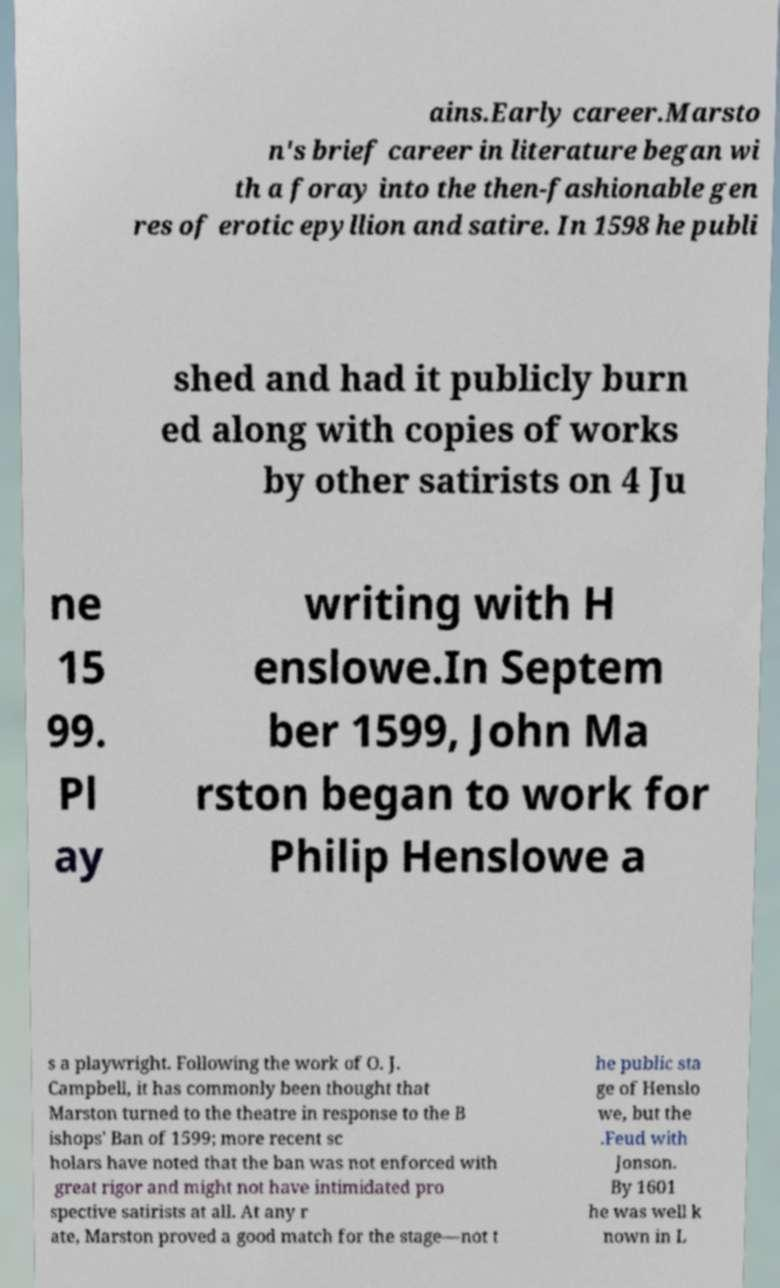For documentation purposes, I need the text within this image transcribed. Could you provide that? ains.Early career.Marsto n's brief career in literature began wi th a foray into the then-fashionable gen res of erotic epyllion and satire. In 1598 he publi shed and had it publicly burn ed along with copies of works by other satirists on 4 Ju ne 15 99. Pl ay writing with H enslowe.In Septem ber 1599, John Ma rston began to work for Philip Henslowe a s a playwright. Following the work of O. J. Campbell, it has commonly been thought that Marston turned to the theatre in response to the B ishops' Ban of 1599; more recent sc holars have noted that the ban was not enforced with great rigor and might not have intimidated pro spective satirists at all. At any r ate, Marston proved a good match for the stage—not t he public sta ge of Henslo we, but the .Feud with Jonson. By 1601 he was well k nown in L 